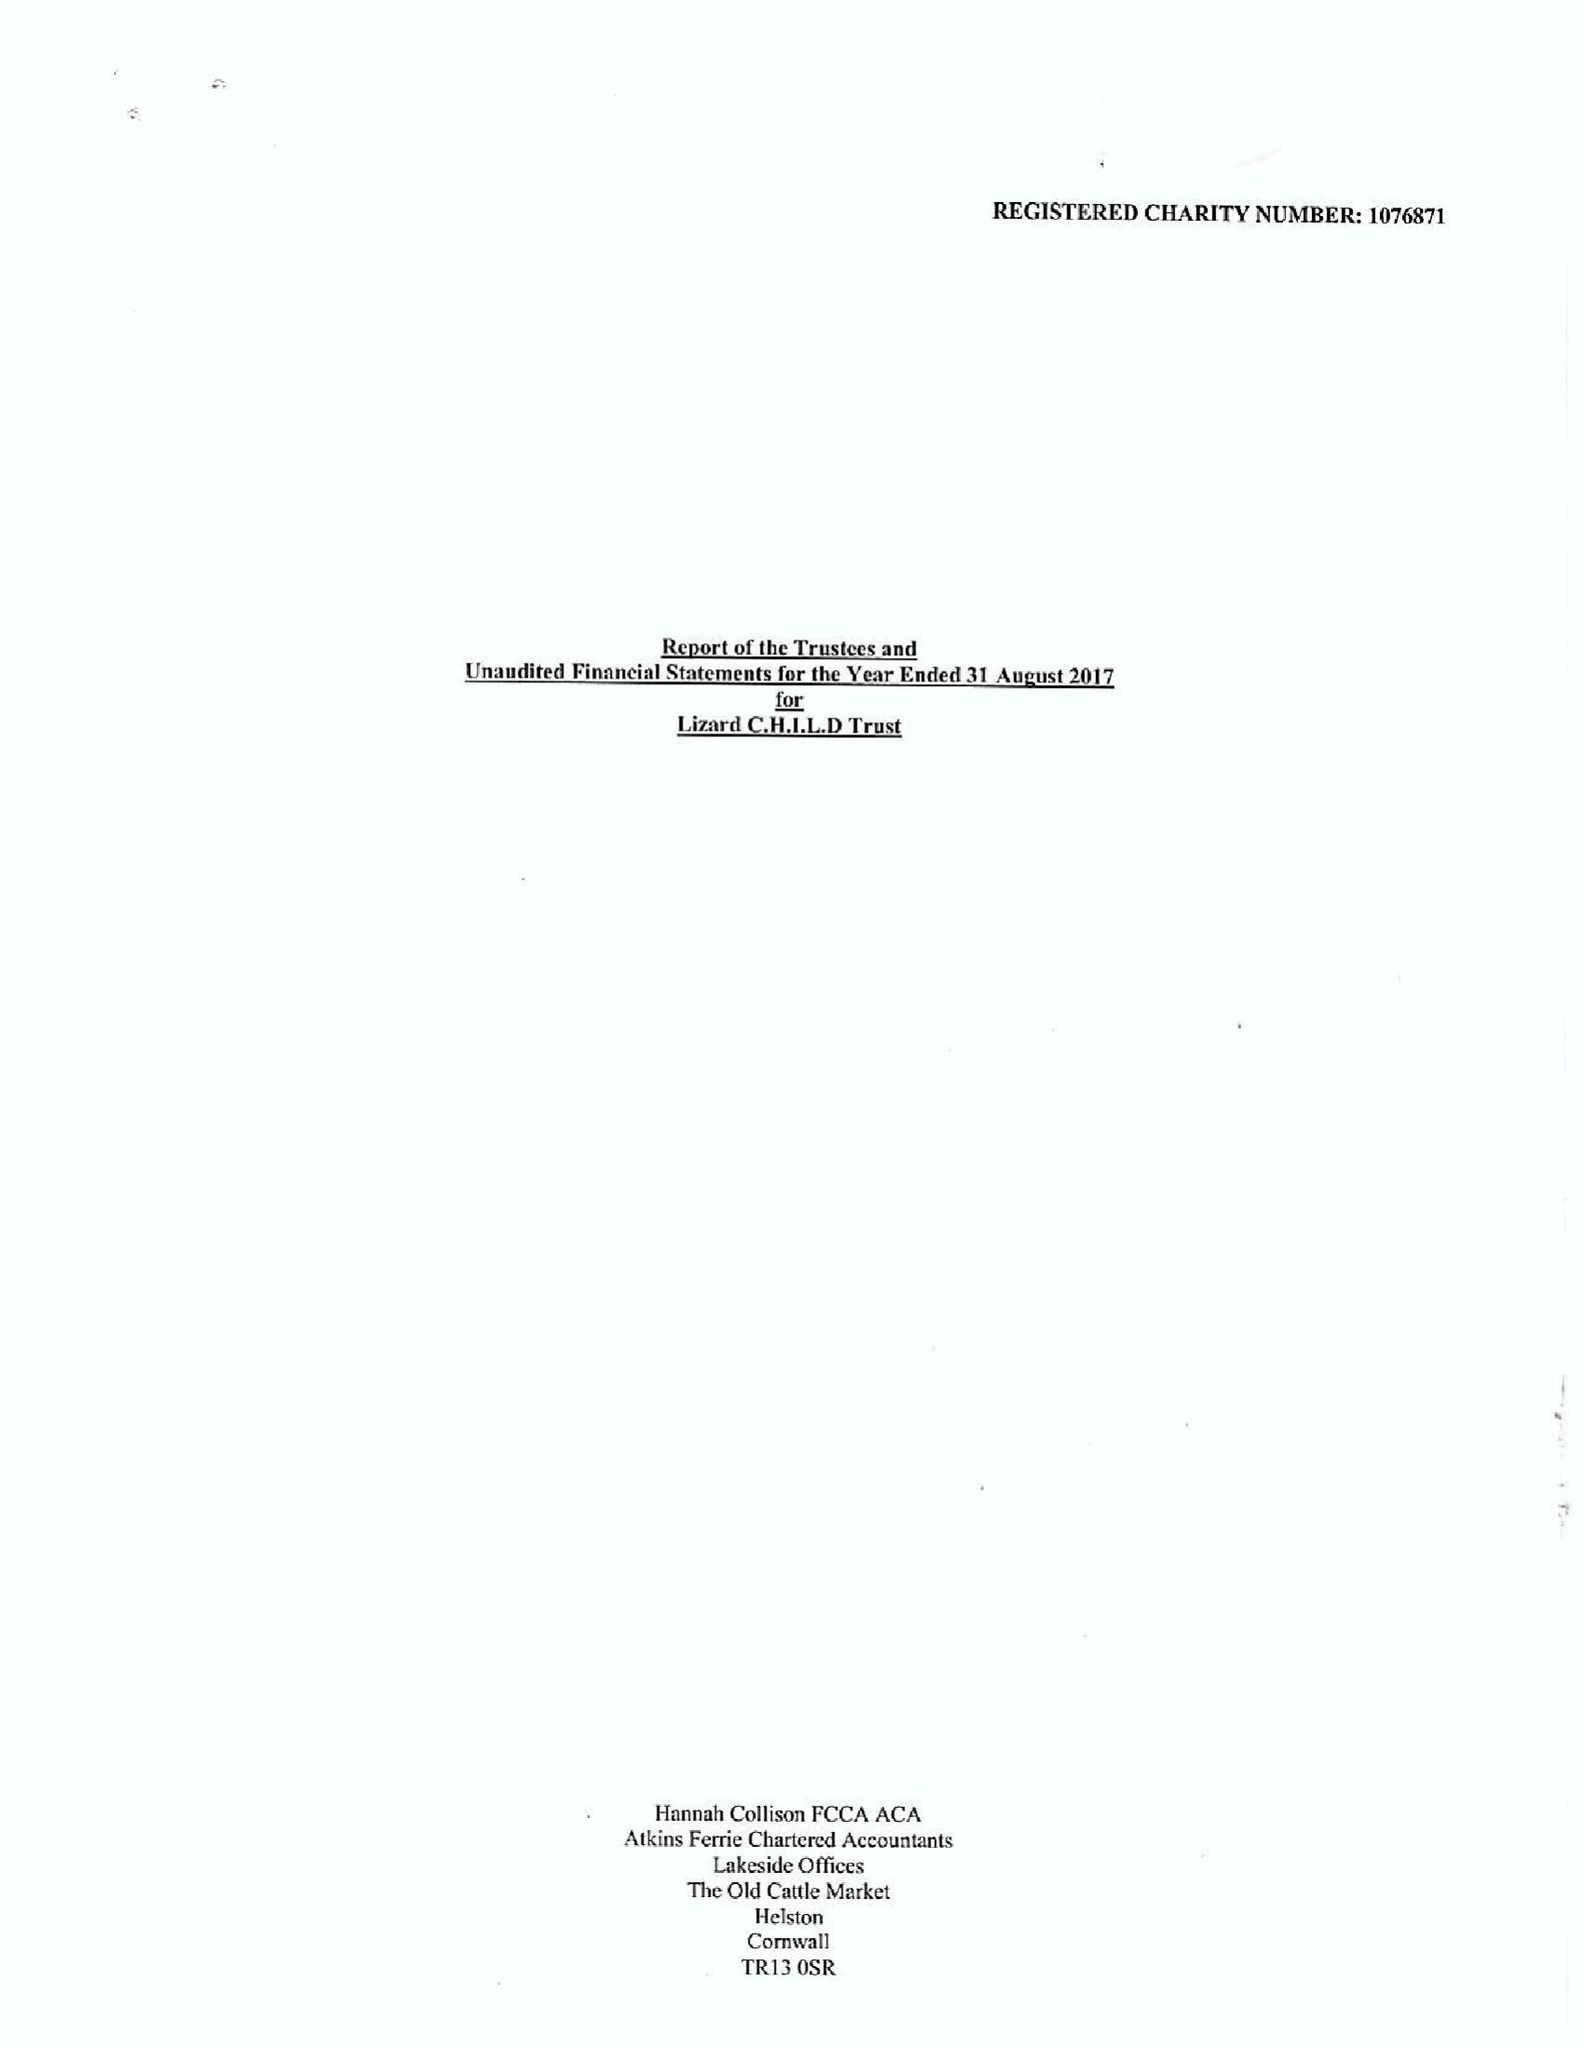What is the value for the address__street_line?
Answer the question using a single word or phrase. PENBERTHY ROAD 